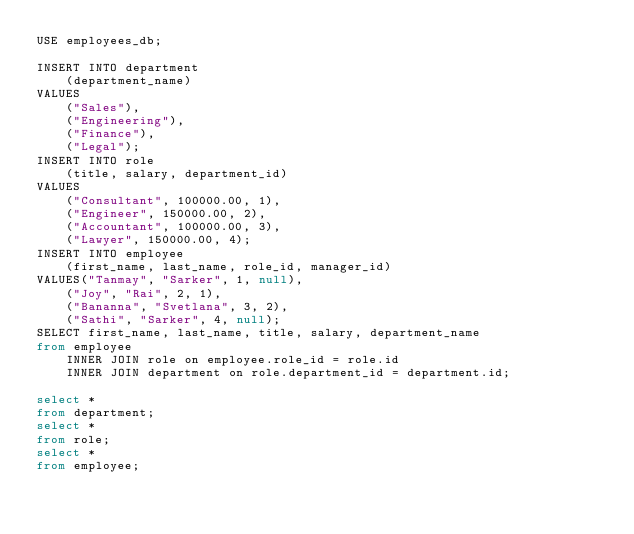Convert code to text. <code><loc_0><loc_0><loc_500><loc_500><_SQL_>USE employees_db;

INSERT INTO department
    (department_name)
VALUES
    ("Sales"),
    ("Engineering"),
    ("Finance"),
    ("Legal");
INSERT INTO role
    (title, salary, department_id)
VALUES
    ("Consultant", 100000.00, 1),
    ("Engineer", 150000.00, 2),
    ("Accountant", 100000.00, 3),
    ("Lawyer", 150000.00, 4);
INSERT INTO employee
    (first_name, last_name, role_id, manager_id)
VALUES("Tanmay", "Sarker", 1, null),
    ("Joy", "Rai", 2, 1),
    ("Bananna", "Svetlana", 3, 2),
    ("Sathi", "Sarker", 4, null);
SELECT first_name, last_name, title, salary, department_name
from employee
    INNER JOIN role on employee.role_id = role.id
    INNER JOIN department on role.department_id = department.id;

select *
from department;
select *
from role;
select *
from employee;


</code> 